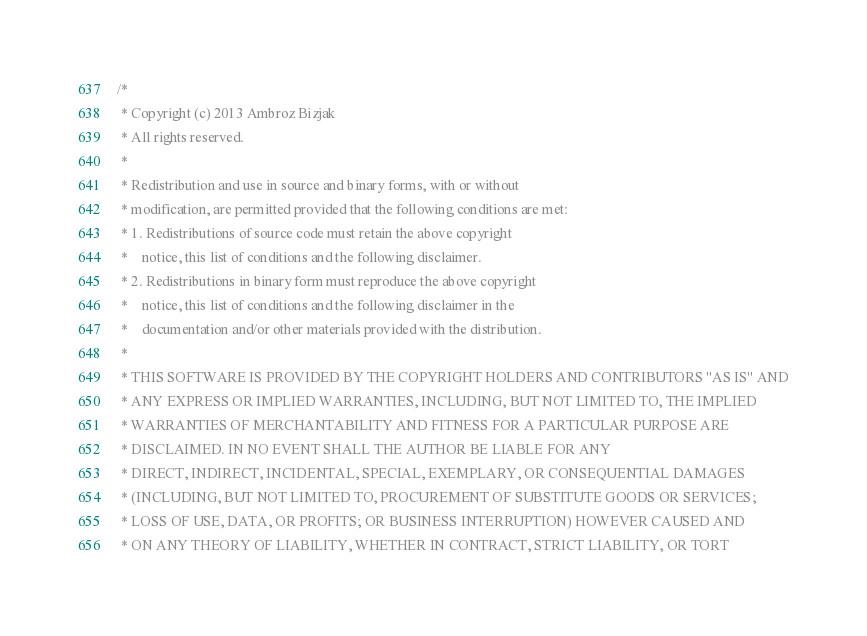<code> <loc_0><loc_0><loc_500><loc_500><_C_>/*
 * Copyright (c) 2013 Ambroz Bizjak
 * All rights reserved.
 * 
 * Redistribution and use in source and binary forms, with or without
 * modification, are permitted provided that the following conditions are met:
 * 1. Redistributions of source code must retain the above copyright
 *    notice, this list of conditions and the following disclaimer.
 * 2. Redistributions in binary form must reproduce the above copyright
 *    notice, this list of conditions and the following disclaimer in the
 *    documentation and/or other materials provided with the distribution.
 * 
 * THIS SOFTWARE IS PROVIDED BY THE COPYRIGHT HOLDERS AND CONTRIBUTORS "AS IS" AND
 * ANY EXPRESS OR IMPLIED WARRANTIES, INCLUDING, BUT NOT LIMITED TO, THE IMPLIED
 * WARRANTIES OF MERCHANTABILITY AND FITNESS FOR A PARTICULAR PURPOSE ARE
 * DISCLAIMED. IN NO EVENT SHALL THE AUTHOR BE LIABLE FOR ANY
 * DIRECT, INDIRECT, INCIDENTAL, SPECIAL, EXEMPLARY, OR CONSEQUENTIAL DAMAGES
 * (INCLUDING, BUT NOT LIMITED TO, PROCUREMENT OF SUBSTITUTE GOODS OR SERVICES;
 * LOSS OF USE, DATA, OR PROFITS; OR BUSINESS INTERRUPTION) HOWEVER CAUSED AND
 * ON ANY THEORY OF LIABILITY, WHETHER IN CONTRACT, STRICT LIABILITY, OR TORT</code> 